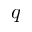<formula> <loc_0><loc_0><loc_500><loc_500>q</formula> 